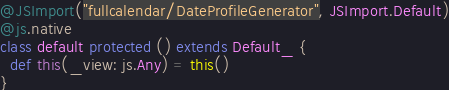<code> <loc_0><loc_0><loc_500><loc_500><_Scala_>@JSImport("fullcalendar/DateProfileGenerator", JSImport.Default)
@js.native
class default protected () extends Default_ {
  def this(_view: js.Any) = this()
}

</code> 